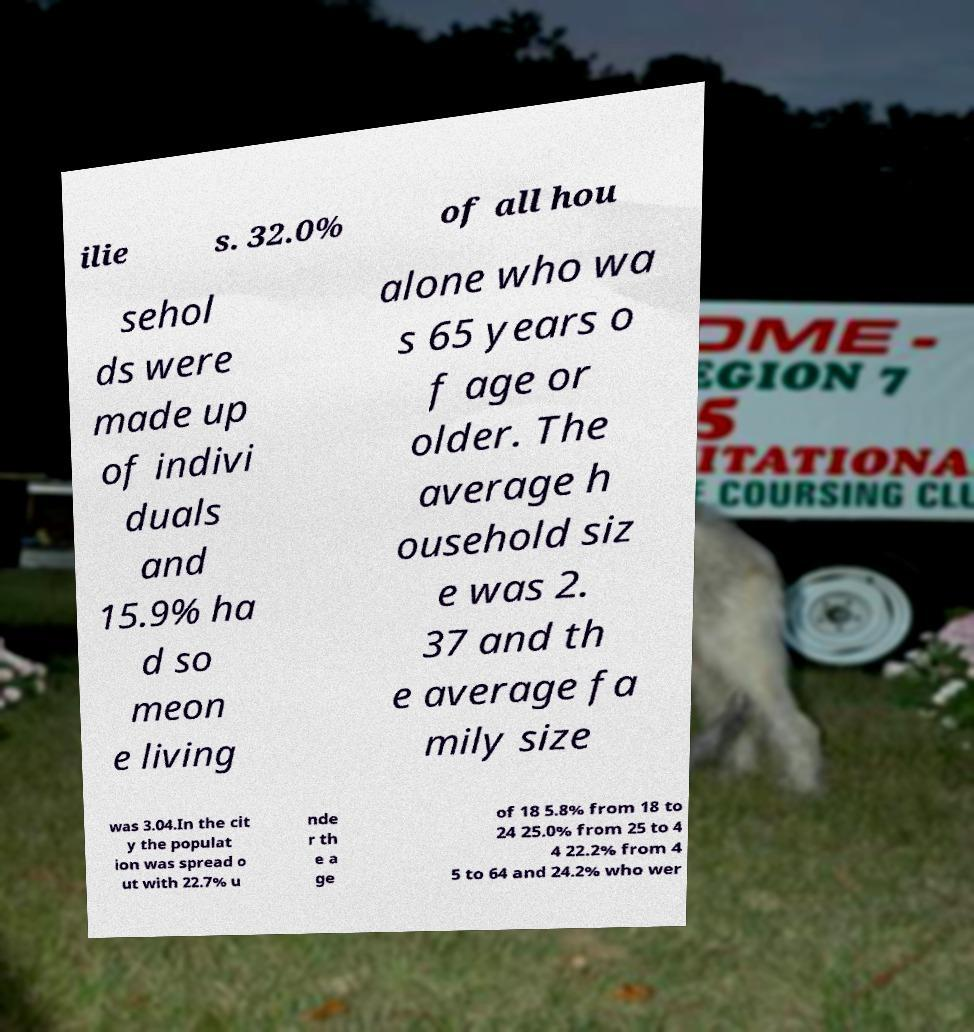For documentation purposes, I need the text within this image transcribed. Could you provide that? ilie s. 32.0% of all hou sehol ds were made up of indivi duals and 15.9% ha d so meon e living alone who wa s 65 years o f age or older. The average h ousehold siz e was 2. 37 and th e average fa mily size was 3.04.In the cit y the populat ion was spread o ut with 22.7% u nde r th e a ge of 18 5.8% from 18 to 24 25.0% from 25 to 4 4 22.2% from 4 5 to 64 and 24.2% who wer 